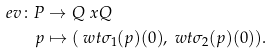Convert formula to latex. <formula><loc_0><loc_0><loc_500><loc_500>e v \colon P & \to Q \ x Q \\ p & \mapsto ( \ w t { \sigma } _ { 1 } ( p ) ( 0 ) , \ w t { \sigma } _ { 2 } ( p ) ( 0 ) ) .</formula> 